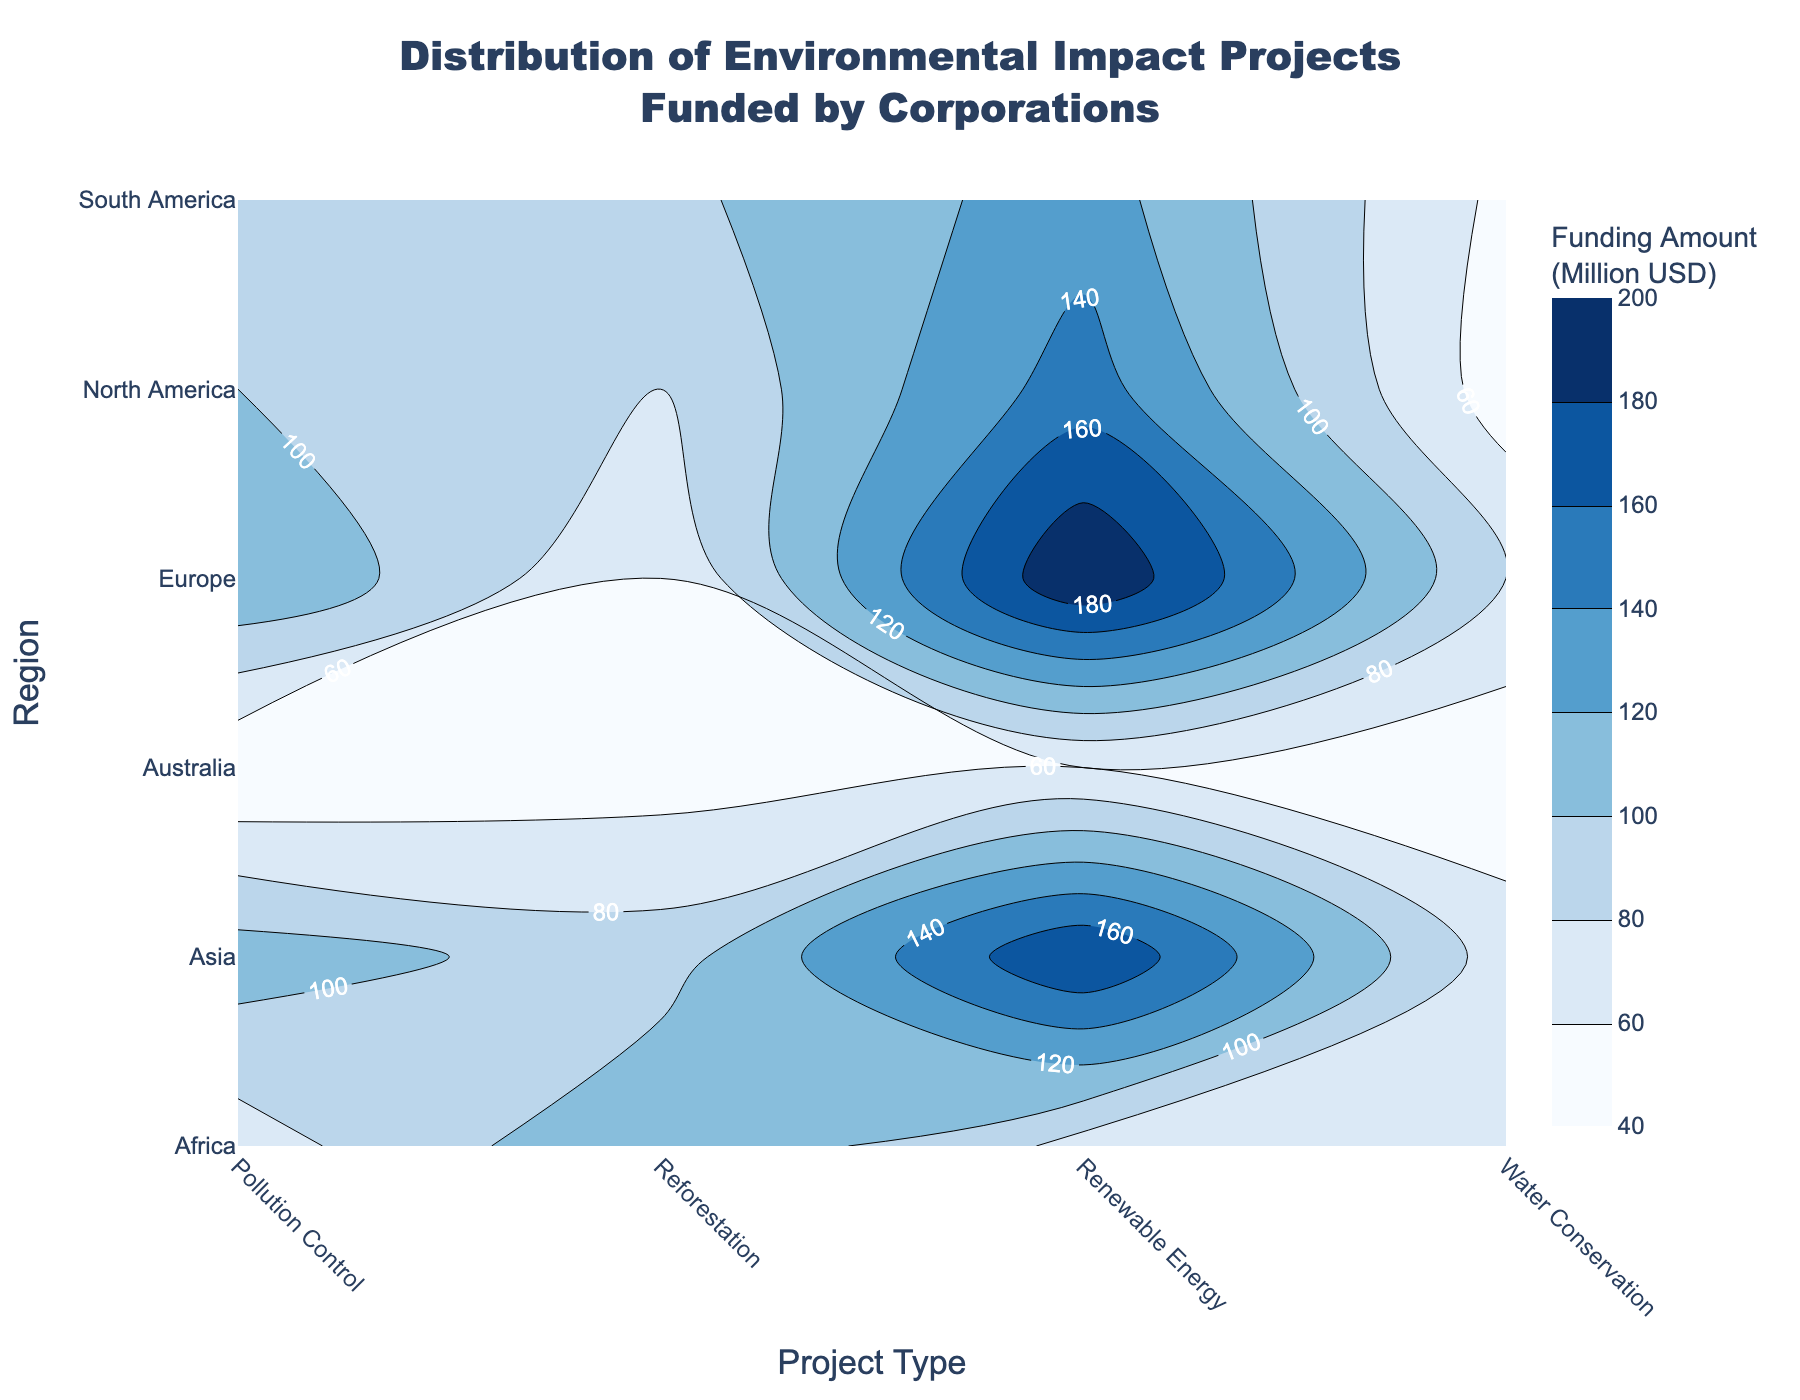What is the highest funding amount for Renewable Energy projects? To find the highest funding amount for Renewable Energy projects, locate the corresponding contour label in the 'Renewable Energy' column for each region. The maximum value is 200 million USD, observed in Europe.
Answer: 200 million USD Which region has the highest total funding across all project types? Summing the funding amounts for each region: North America (380), Europe (460), Asia (450), South America (370), Africa (330), Australia (195). The region with the highest total is Europe.
Answer: Europe Are there any regions where Reforestation projects received more funding than Renewable Energy projects? Compare the funding amounts for Reforestation and Renewable Energy within the same row for each region. Reforestation has more funding in Africa (120 vs 75).
Answer: Africa What is the difference in funding amount for Pollution Control projects between Asia and Australia? Refer to the 'Pollution Control' column and subtract Australia's value (40) from Asia's value (110): 110 - 40 = 70 million USD.
Answer: 70 million USD How does the funding amount for Water Conservation in South America compare to that in North America? Look at 'Water Conservation' for South America (55) and North America (50). The funding in South America is slightly higher.
Answer: South America has more What is the average funding amount for Renewal Energy projects across all regions? Sum the amounts for Renewable Energy across all regions: 150 + 200 + 180 + 130 + 75 + 60 = 795 million USD. Divide by the number of regions (6): 795/6 = 132.5 million USD.
Answer: 132.5 million USD Is there any region where the funding for Water Conservation is the highest among all other project types? Compare the funding amounts for Water Conservation with those for Renewable Energy, Reforestation, and Pollution Control within the same region. There is no such region.
Answer: No Which project type has the least variation in funding amounts across regions? By visually examining the contour variations for each project type column, Pollution Control seems to have the least variation compared to others.
Answer: Pollution Control Describe the funding distribution for Reforestation projects across regions. The funding amounts for Reforestation in each region are North America (80), Europe (60), Asia (90), South America (95), Africa (120), and Australia (50), with the highest in Africa and the lowest in Australia.
Answer: Highest in Africa, lowest in Australia Which project type receives the most consistent funding between North America and Europe? Compare the funding amounts between North America and Europe for each project type. Pollution Control funding is 100 in North America and 120 in Europe, showing the smallest difference.
Answer: Pollution Control 